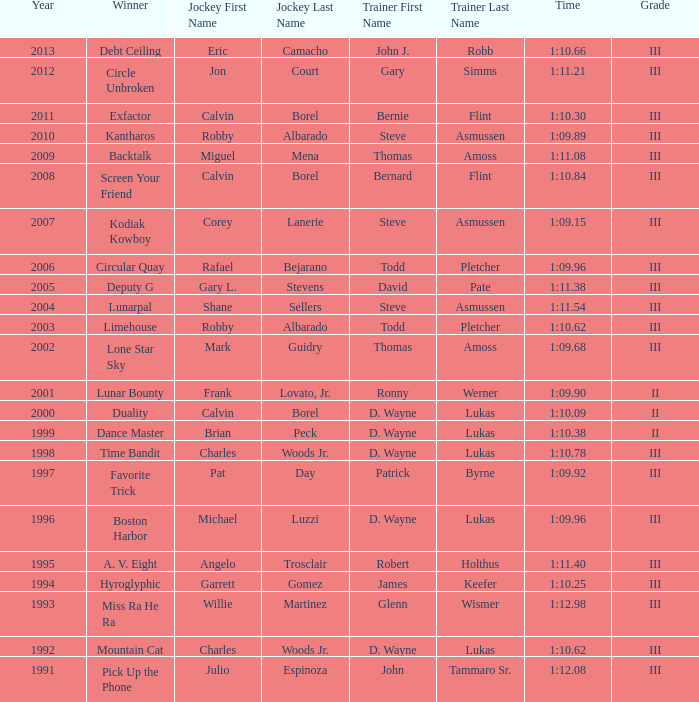Which trainer won the hyroglyphic in a year that was before 2010? James Keefer. 